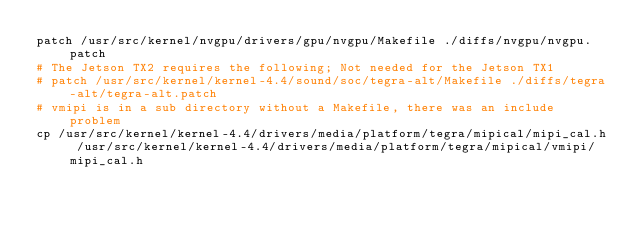<code> <loc_0><loc_0><loc_500><loc_500><_Bash_>patch /usr/src/kernel/nvgpu/drivers/gpu/nvgpu/Makefile ./diffs/nvgpu/nvgpu.patch
# The Jetson TX2 requires the following; Not needed for the Jetson TX1
# patch /usr/src/kernel/kernel-4.4/sound/soc/tegra-alt/Makefile ./diffs/tegra-alt/tegra-alt.patch
# vmipi is in a sub directory without a Makefile, there was an include problem
cp /usr/src/kernel/kernel-4.4/drivers/media/platform/tegra/mipical/mipi_cal.h /usr/src/kernel/kernel-4.4/drivers/media/platform/tegra/mipical/vmipi/mipi_cal.h
 

</code> 